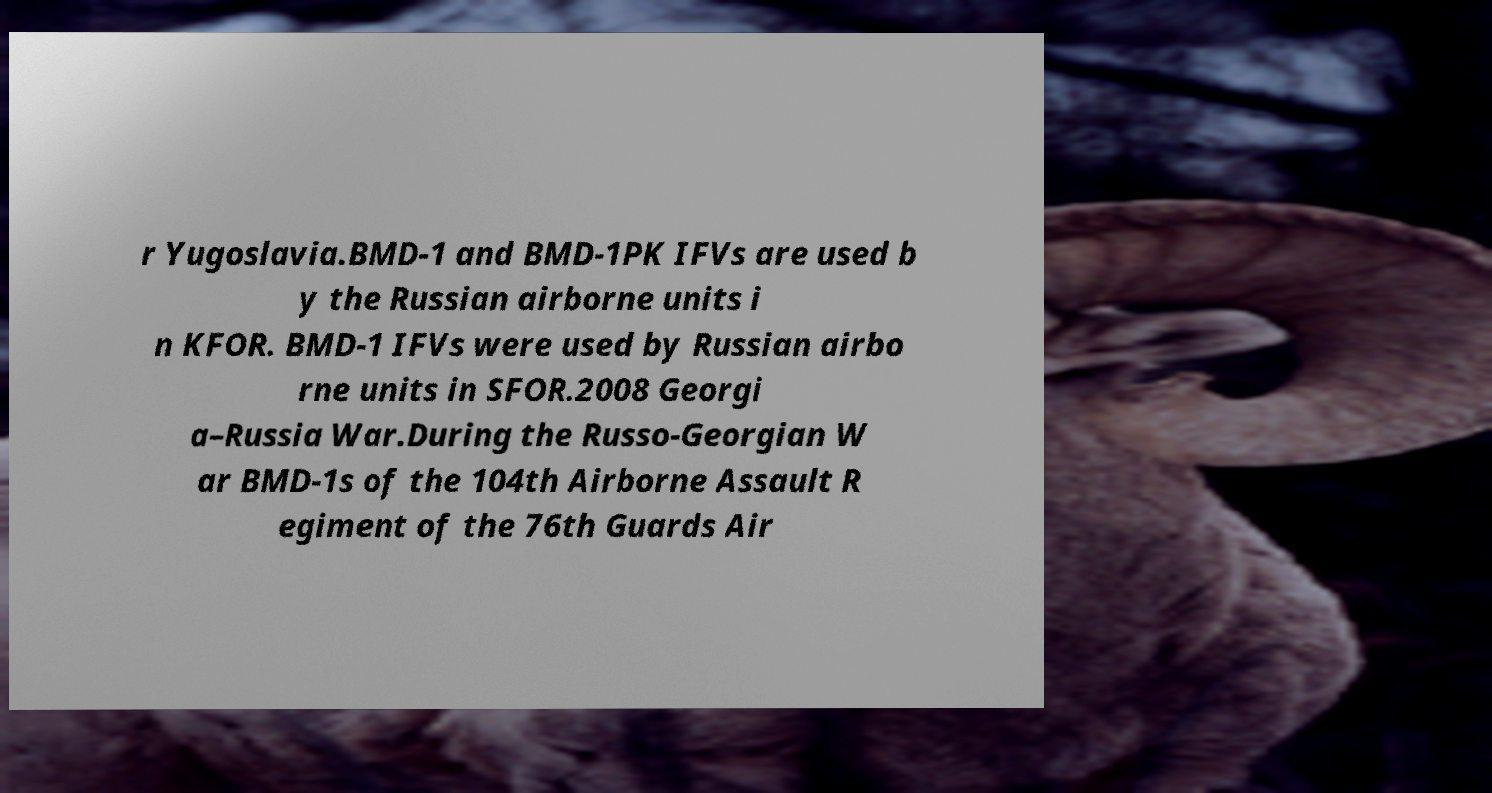Could you extract and type out the text from this image? r Yugoslavia.BMD-1 and BMD-1PK IFVs are used b y the Russian airborne units i n KFOR. BMD-1 IFVs were used by Russian airbo rne units in SFOR.2008 Georgi a–Russia War.During the Russo-Georgian W ar BMD-1s of the 104th Airborne Assault R egiment of the 76th Guards Air 